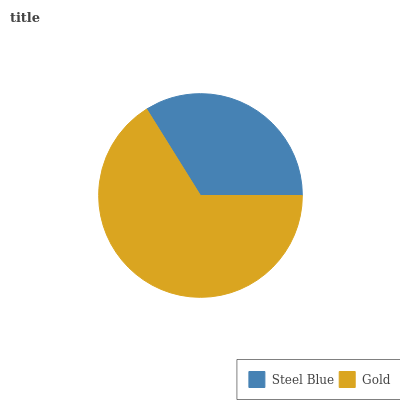Is Steel Blue the minimum?
Answer yes or no. Yes. Is Gold the maximum?
Answer yes or no. Yes. Is Gold the minimum?
Answer yes or no. No. Is Gold greater than Steel Blue?
Answer yes or no. Yes. Is Steel Blue less than Gold?
Answer yes or no. Yes. Is Steel Blue greater than Gold?
Answer yes or no. No. Is Gold less than Steel Blue?
Answer yes or no. No. Is Gold the high median?
Answer yes or no. Yes. Is Steel Blue the low median?
Answer yes or no. Yes. Is Steel Blue the high median?
Answer yes or no. No. Is Gold the low median?
Answer yes or no. No. 